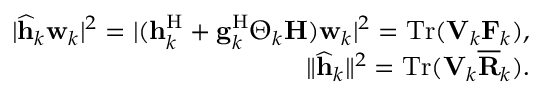<formula> <loc_0><loc_0><loc_500><loc_500>\begin{array} { r l r } & { | \widehat { h } _ { k } w _ { k } | ^ { 2 } = | ( h _ { k } ^ { H } + g _ { k } ^ { H } \Theta _ { k } H ) w _ { k } | ^ { 2 } = T r ( V _ { k } F _ { k } ) , } \\ & { \| \widehat { h } _ { k } \| ^ { 2 } = T r ( V _ { k } \overline { R } _ { k } ) . } \end{array}</formula> 